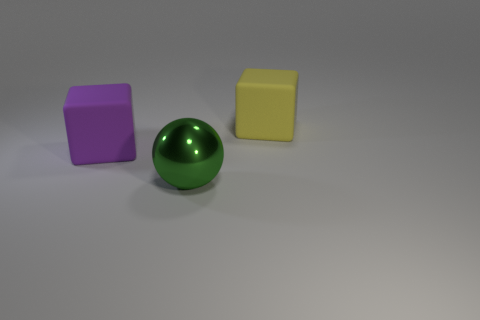What number of other objects are there of the same material as the big green thing?
Make the answer very short. 0. Is the material of the yellow cube the same as the purple thing?
Offer a terse response. Yes. There is a thing that is behind the large purple object left of the yellow object; is there a big matte block that is to the left of it?
Your answer should be compact. Yes. The purple matte thing that is the same size as the yellow matte block is what shape?
Ensure brevity in your answer.  Cube. What number of small things are gray matte objects or yellow objects?
Make the answer very short. 0. The big thing that is made of the same material as the large yellow cube is what color?
Give a very brief answer. Purple. There is a thing on the left side of the large metallic thing; is its shape the same as the big matte thing that is right of the large shiny sphere?
Your answer should be very brief. Yes. How many shiny objects are green objects or purple cubes?
Offer a very short reply. 1. Are there any other things that have the same shape as the green metal thing?
Ensure brevity in your answer.  No. What is the material of the object behind the large purple rubber cube?
Provide a short and direct response. Rubber. 